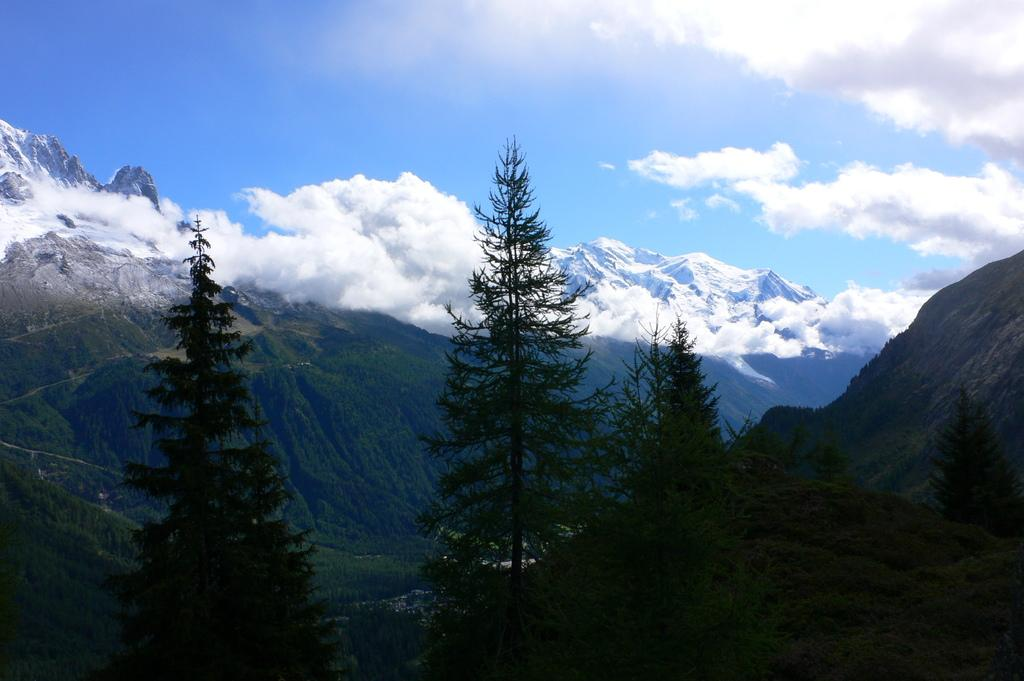What type of natural vegetation can be seen in the image? There are trees in the image. What geographical feature is visible in the image? There are mountains with snow in the image. What is visible at the top of the image? The sky is visible at the top of the image. What can be seen in the sky in the image? Clouds are present in the sky. Where are the flowers located in the image? There are no flowers present in the image. Can you describe the basket that is hanging from the tree in the image? There is no basket hanging from a tree in the image. 